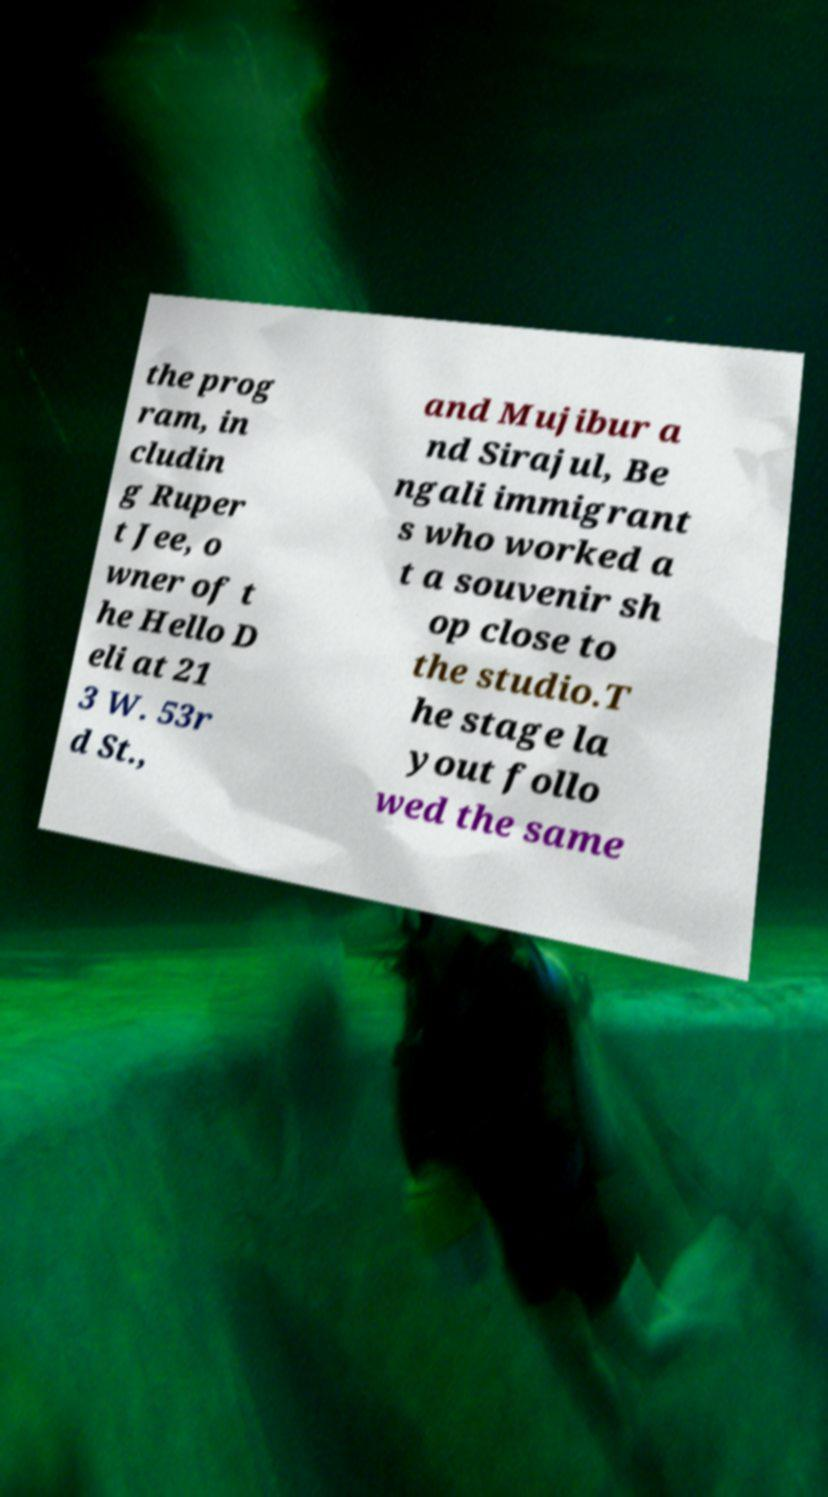Can you accurately transcribe the text from the provided image for me? the prog ram, in cludin g Ruper t Jee, o wner of t he Hello D eli at 21 3 W. 53r d St., and Mujibur a nd Sirajul, Be ngali immigrant s who worked a t a souvenir sh op close to the studio.T he stage la yout follo wed the same 